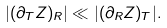<formula> <loc_0><loc_0><loc_500><loc_500>| ( \partial _ { T } Z ) _ { R } | \ll | ( \partial _ { R } Z ) _ { T } | .</formula> 